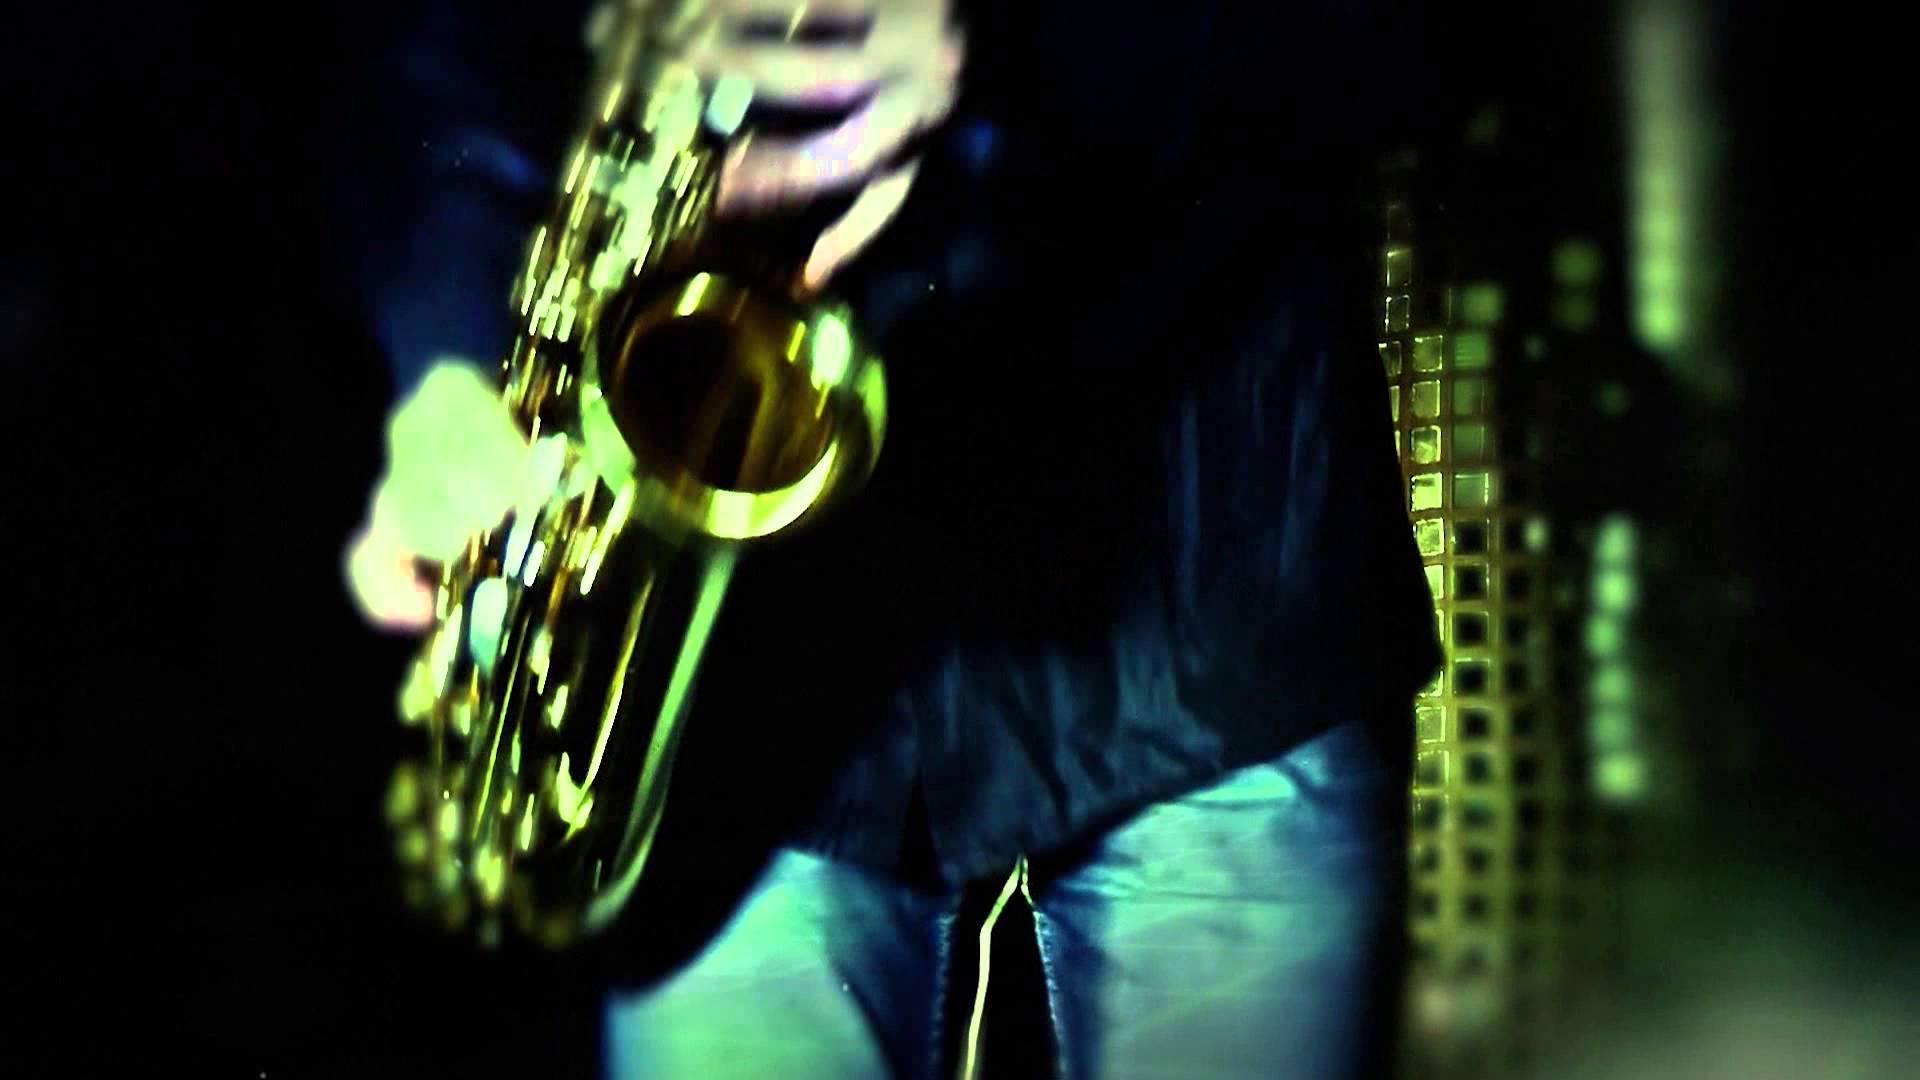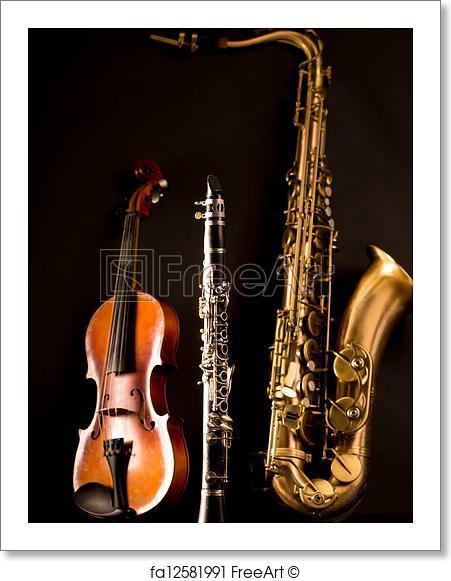The first image is the image on the left, the second image is the image on the right. Examine the images to the left and right. Is the description "The lefthand image includes a woman in a cleavage-baring dress standing and holding a saxophone in front of a woman standing and playing violin." accurate? Answer yes or no. No. The first image is the image on the left, the second image is the image on the right. Considering the images on both sides, is "There are exactly two people in the left image." valid? Answer yes or no. No. 